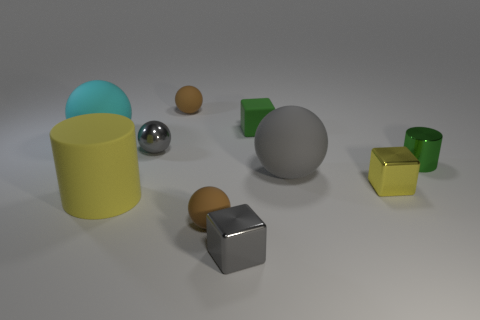Subtract all small metal spheres. How many spheres are left? 4 Subtract all cyan spheres. How many spheres are left? 4 Subtract all yellow spheres. Subtract all gray cubes. How many spheres are left? 5 Subtract all cylinders. How many objects are left? 8 Add 5 tiny brown rubber spheres. How many tiny brown rubber spheres are left? 7 Add 7 cyan matte objects. How many cyan matte objects exist? 8 Subtract 0 purple blocks. How many objects are left? 10 Subtract all small metallic objects. Subtract all small brown matte things. How many objects are left? 4 